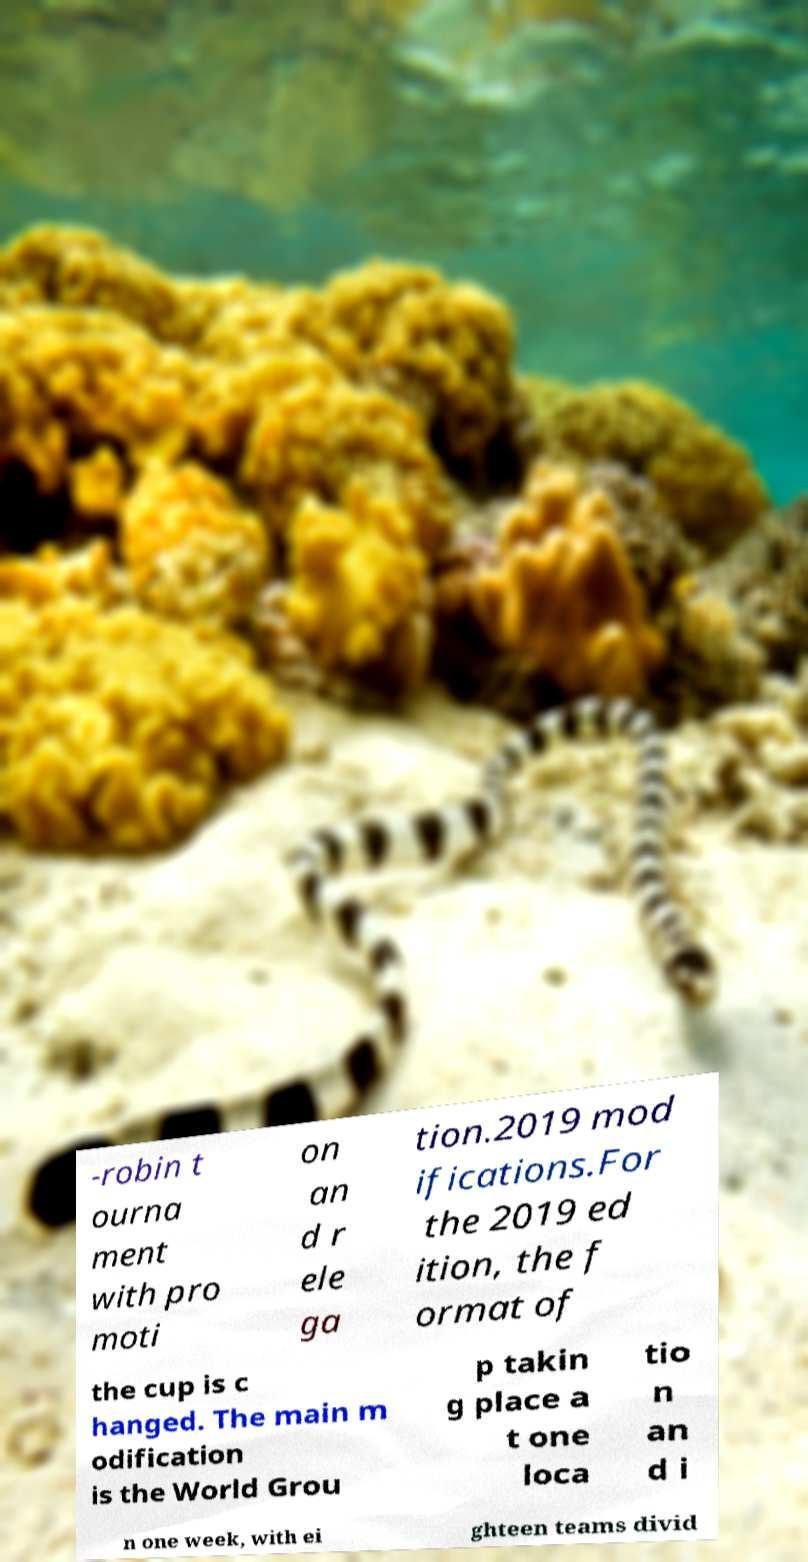I need the written content from this picture converted into text. Can you do that? -robin t ourna ment with pro moti on an d r ele ga tion.2019 mod ifications.For the 2019 ed ition, the f ormat of the cup is c hanged. The main m odification is the World Grou p takin g place a t one loca tio n an d i n one week, with ei ghteen teams divid 